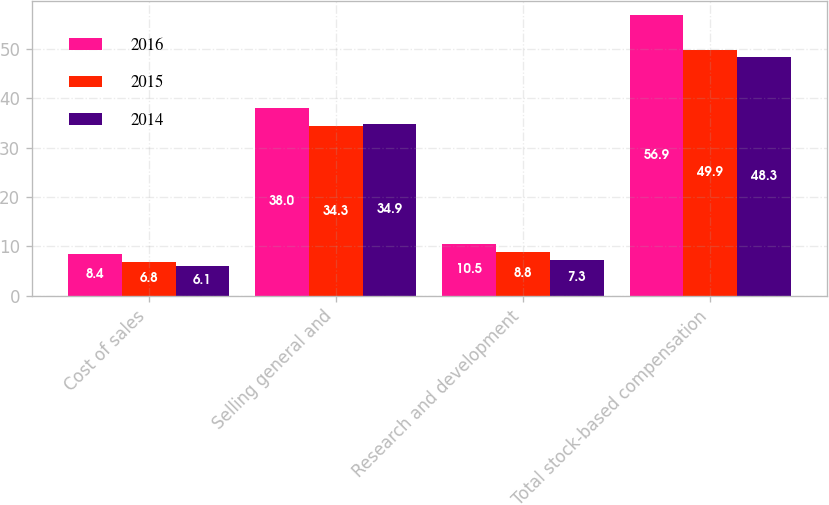Convert chart. <chart><loc_0><loc_0><loc_500><loc_500><stacked_bar_chart><ecel><fcel>Cost of sales<fcel>Selling general and<fcel>Research and development<fcel>Total stock-based compensation<nl><fcel>2016<fcel>8.4<fcel>38<fcel>10.5<fcel>56.9<nl><fcel>2015<fcel>6.8<fcel>34.3<fcel>8.8<fcel>49.9<nl><fcel>2014<fcel>6.1<fcel>34.9<fcel>7.3<fcel>48.3<nl></chart> 